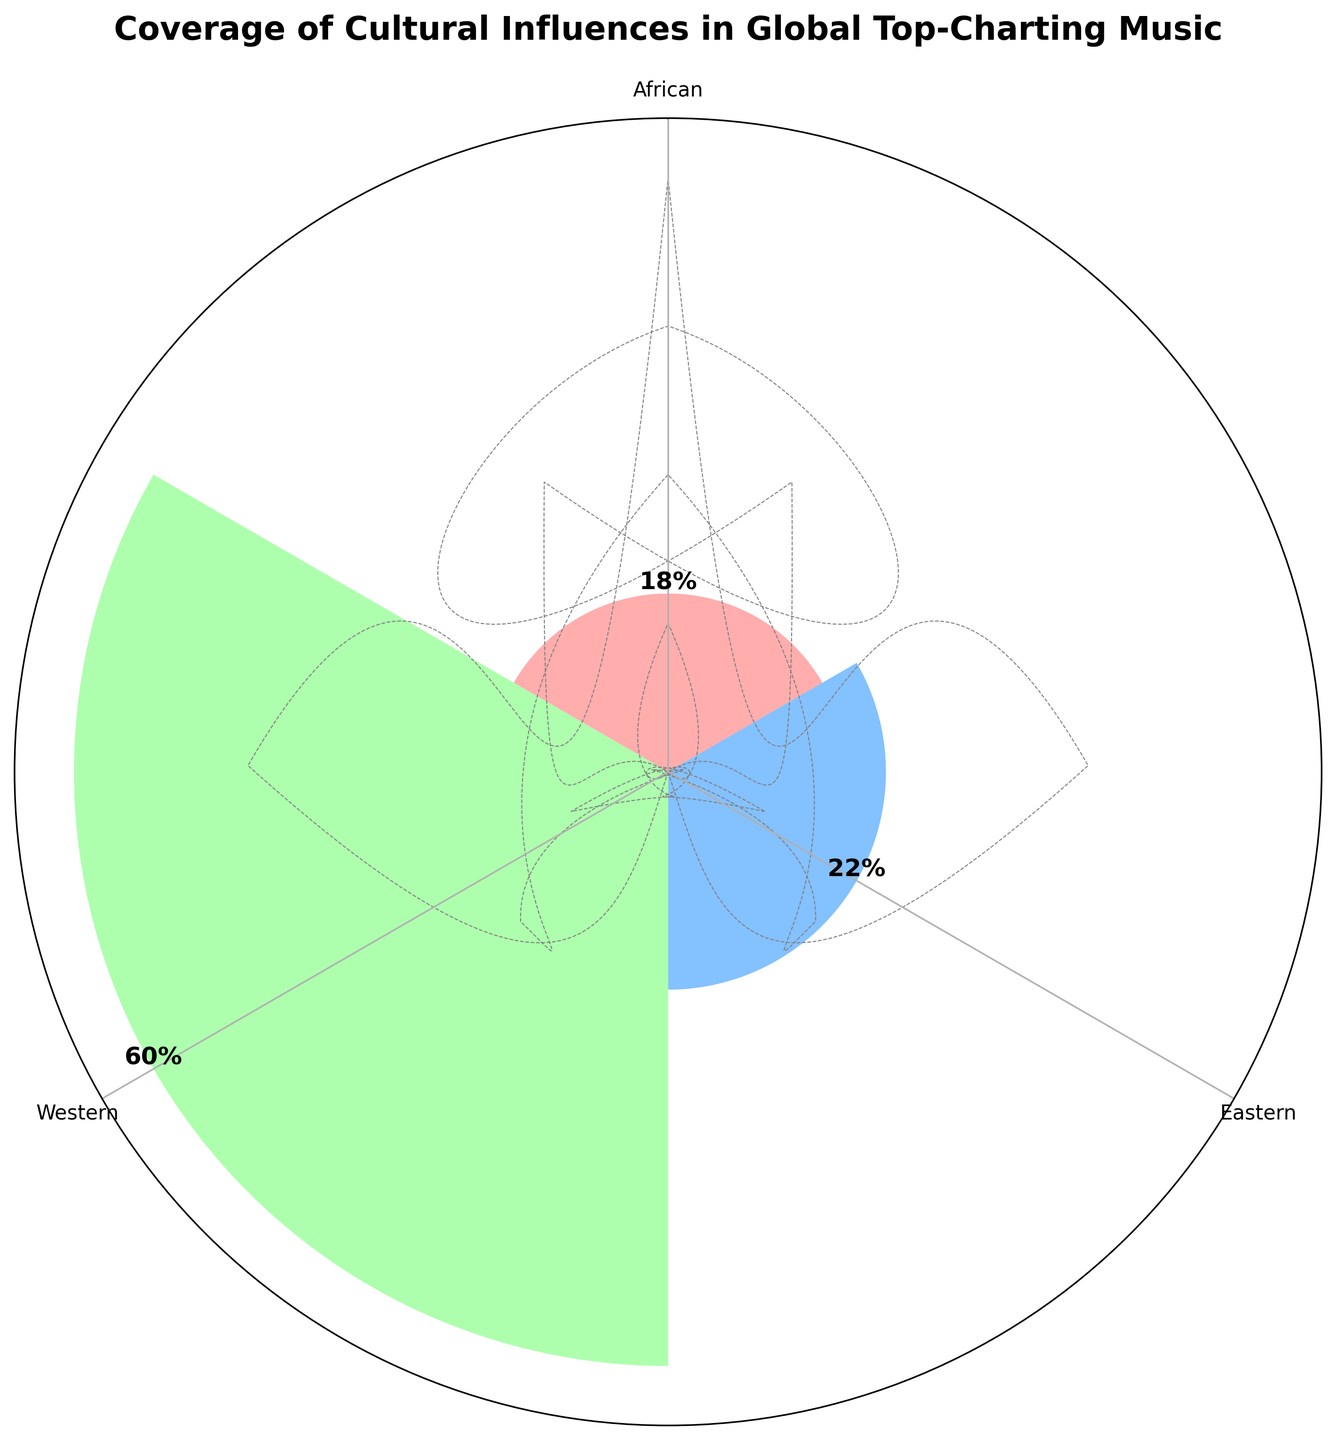What's the title of the figure? The title of the figure is usually located at the top, centered above the chart. It summarizes the main focus of the chart.
Answer: Coverage of Cultural Influences in Global Top-Charting Music Which cultural group has the highest percentage of global top-charting music? The group with the highest percentage can be identified by comparing the heights of the bars. The tallest bar indicates the group with the highest percentage.
Answer: Western How many cultural groups are represented in the figure? The number of cultural groups represented can be counted by identifying the distinct labels on the chart.
Answer: Three (Western, Eastern, African) Compare the percentages of Western and Eastern influences. What is the difference between them? To find the difference, we look at the percentages for Western (60%) and Eastern (22%). Subtract the smaller percentage from the larger one. Difference = 60 - 22 = 38.
Answer: 38% What is the combined coverage percentage of African influences? To find the combined coverage percentage for African influences, sum up the percentages labeled under African. 10% (Burna Boy) + 8% (Wizkid) = 18%.
Answer: 18% Which individual music artist has the highest percentage representation in this chart? Identify the artist with the highest individual percentage by comparing the percentage values associated with each artist.
Answer: Taylor Swift (25%) What percentage does Drake contribute to the Western cultural influences? Look at the percentage value associated with Drake in the Western segment of the chart.
Answer: 15% Are Eastern influences represented more strongly than African influences? Compare the combined coverage percentages of Eastern (22%) and African (18%) cultural influences. Since 22% > 18%, Eastern is stronger.
Answer: Yes Sum the contributions of all Western artists. Add the percentages of all artists labeled under Western: 25% (Taylor Swift) + 20% (Ed Sheeran) + 15% (Drake) = 60%.
Answer: 60% Identify one aspect unique to rose charts visible in this figure. Rose charts have a unique circular layout where different segments (or bars) radiate outward from the center, each corresponding to a group with variable lengths representing the data values.
Answer: Circular Segments 